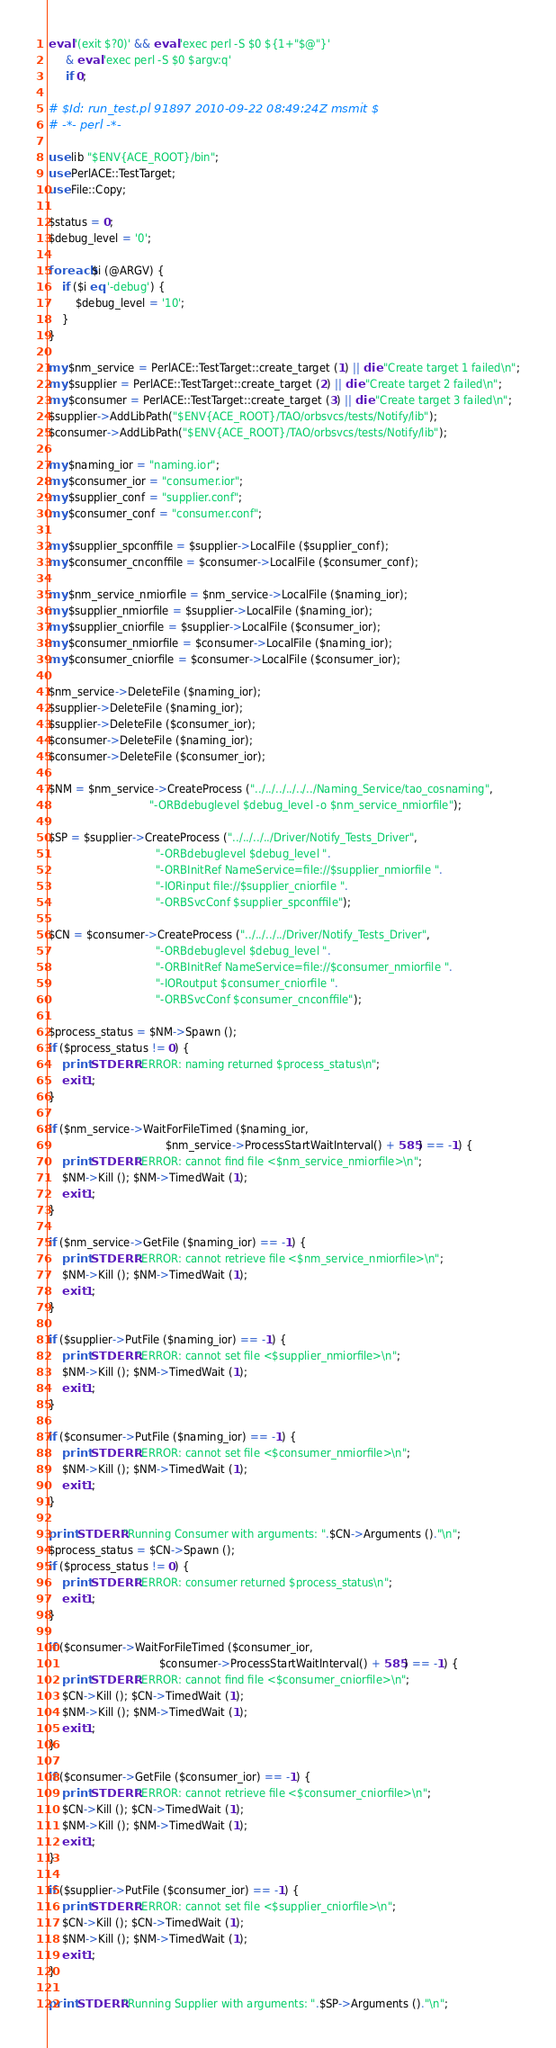Convert code to text. <code><loc_0><loc_0><loc_500><loc_500><_Perl_>eval '(exit $?0)' && eval 'exec perl -S $0 ${1+"$@"}'
     & eval 'exec perl -S $0 $argv:q'
     if 0;

# $Id: run_test.pl 91897 2010-09-22 08:49:24Z msmit $
# -*- perl -*-

use lib "$ENV{ACE_ROOT}/bin";
use PerlACE::TestTarget;
use File::Copy;

$status = 0;
$debug_level = '0';

foreach $i (@ARGV) {
    if ($i eq '-debug') {
        $debug_level = '10';
    }
}

my $nm_service = PerlACE::TestTarget::create_target (1) || die "Create target 1 failed\n";
my $supplier = PerlACE::TestTarget::create_target (2) || die "Create target 2 failed\n";
my $consumer = PerlACE::TestTarget::create_target (3) || die "Create target 3 failed\n";
$supplier->AddLibPath("$ENV{ACE_ROOT}/TAO/orbsvcs/tests/Notify/lib");
$consumer->AddLibPath("$ENV{ACE_ROOT}/TAO/orbsvcs/tests/Notify/lib");

my $naming_ior = "naming.ior";
my $consumer_ior = "consumer.ior";
my $supplier_conf = "supplier.conf";
my $consumer_conf = "consumer.conf";

my $supplier_spconffile = $supplier->LocalFile ($supplier_conf);
my $consumer_cnconffile = $consumer->LocalFile ($consumer_conf);

my $nm_service_nmiorfile = $nm_service->LocalFile ($naming_ior);
my $supplier_nmiorfile = $supplier->LocalFile ($naming_ior);
my $supplier_cniorfile = $supplier->LocalFile ($consumer_ior);
my $consumer_nmiorfile = $consumer->LocalFile ($naming_ior);
my $consumer_cniorfile = $consumer->LocalFile ($consumer_ior);

$nm_service->DeleteFile ($naming_ior);
$supplier->DeleteFile ($naming_ior);
$supplier->DeleteFile ($consumer_ior);
$consumer->DeleteFile ($naming_ior);
$consumer->DeleteFile ($consumer_ior);

$NM = $nm_service->CreateProcess ("../../../../../../Naming_Service/tao_cosnaming",
                              "-ORBdebuglevel $debug_level -o $nm_service_nmiorfile");

$SP = $supplier->CreateProcess ("../../../../Driver/Notify_Tests_Driver",
                                "-ORBdebuglevel $debug_level ".
                                "-ORBInitRef NameService=file://$supplier_nmiorfile ".
                                "-IORinput file://$supplier_cniorfile ".
                                "-ORBSvcConf $supplier_spconffile");

$CN = $consumer->CreateProcess ("../../../../Driver/Notify_Tests_Driver",
                                "-ORBdebuglevel $debug_level ".
                                "-ORBInitRef NameService=file://$consumer_nmiorfile ".
                                "-IORoutput $consumer_cniorfile ".
                                "-ORBSvcConf $consumer_cnconffile");

$process_status = $NM->Spawn ();
if ($process_status != 0) {
    print STDERR "ERROR: naming returned $process_status\n";
    exit 1;
}

if ($nm_service->WaitForFileTimed ($naming_ior,
                                   $nm_service->ProcessStartWaitInterval() + 585) == -1) {
    print STDERR "ERROR: cannot find file <$nm_service_nmiorfile>\n";
    $NM->Kill (); $NM->TimedWait (1);
    exit 1;
}

if ($nm_service->GetFile ($naming_ior) == -1) {
    print STDERR "ERROR: cannot retrieve file <$nm_service_nmiorfile>\n";
    $NM->Kill (); $NM->TimedWait (1);
    exit 1;
}

if ($supplier->PutFile ($naming_ior) == -1) {
    print STDERR "ERROR: cannot set file <$supplier_nmiorfile>\n";
    $NM->Kill (); $NM->TimedWait (1);
    exit 1;
}

if ($consumer->PutFile ($naming_ior) == -1) {
    print STDERR "ERROR: cannot set file <$consumer_nmiorfile>\n";
    $NM->Kill (); $NM->TimedWait (1);
    exit 1;
}

print STDERR "Running Consumer with arguments: ".$CN->Arguments ()."\n";
$process_status = $CN->Spawn ();
if ($process_status != 0) {
    print STDERR "ERROR: consumer returned $process_status\n";
    exit 1;
}

if ($consumer->WaitForFileTimed ($consumer_ior,
                                 $consumer->ProcessStartWaitInterval() + 585) == -1) {
    print STDERR "ERROR: cannot find file <$consumer_cniorfile>\n";
    $CN->Kill (); $CN->TimedWait (1);
    $NM->Kill (); $NM->TimedWait (1);
    exit 1;
}

if ($consumer->GetFile ($consumer_ior) == -1) {
    print STDERR "ERROR: cannot retrieve file <$consumer_cniorfile>\n";
    $CN->Kill (); $CN->TimedWait (1);
    $NM->Kill (); $NM->TimedWait (1);
    exit 1;
}

if ($supplier->PutFile ($consumer_ior) == -1) {
    print STDERR "ERROR: cannot set file <$supplier_cniorfile>\n";
    $CN->Kill (); $CN->TimedWait (1);
    $NM->Kill (); $NM->TimedWait (1);
    exit 1;
}

print STDERR "Running Supplier with arguments: ".$SP->Arguments ()."\n";</code> 